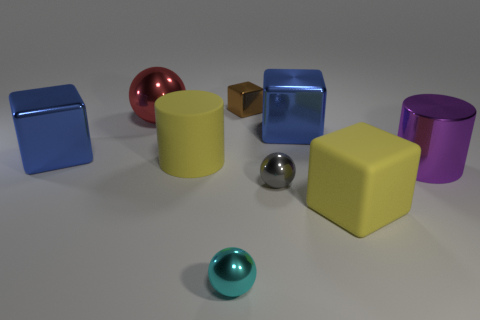The thing that is the same color as the large rubber cylinder is what shape?
Your response must be concise. Cube. Is the material of the big block to the left of the brown cube the same as the cylinder behind the purple metal cylinder?
Keep it short and to the point. No. What shape is the large yellow matte object that is right of the big cylinder behind the metallic cylinder?
Provide a succinct answer. Cube. Are there any other things that have the same color as the tiny block?
Your answer should be very brief. No. There is a purple shiny object that is in front of the blue shiny object that is on the left side of the cyan object; are there any large matte objects on the right side of it?
Offer a terse response. No. There is a big rubber object that is left of the gray metallic ball; does it have the same color as the large block in front of the yellow cylinder?
Ensure brevity in your answer.  Yes. There is a yellow block that is the same size as the shiny cylinder; what is its material?
Offer a terse response. Rubber. There is a sphere that is behind the big metal thing that is in front of the matte thing behind the tiny gray metallic sphere; what is its size?
Your response must be concise. Large. What number of other things are made of the same material as the small gray ball?
Provide a succinct answer. 6. There is a ball that is to the right of the tiny brown thing; how big is it?
Ensure brevity in your answer.  Small. 